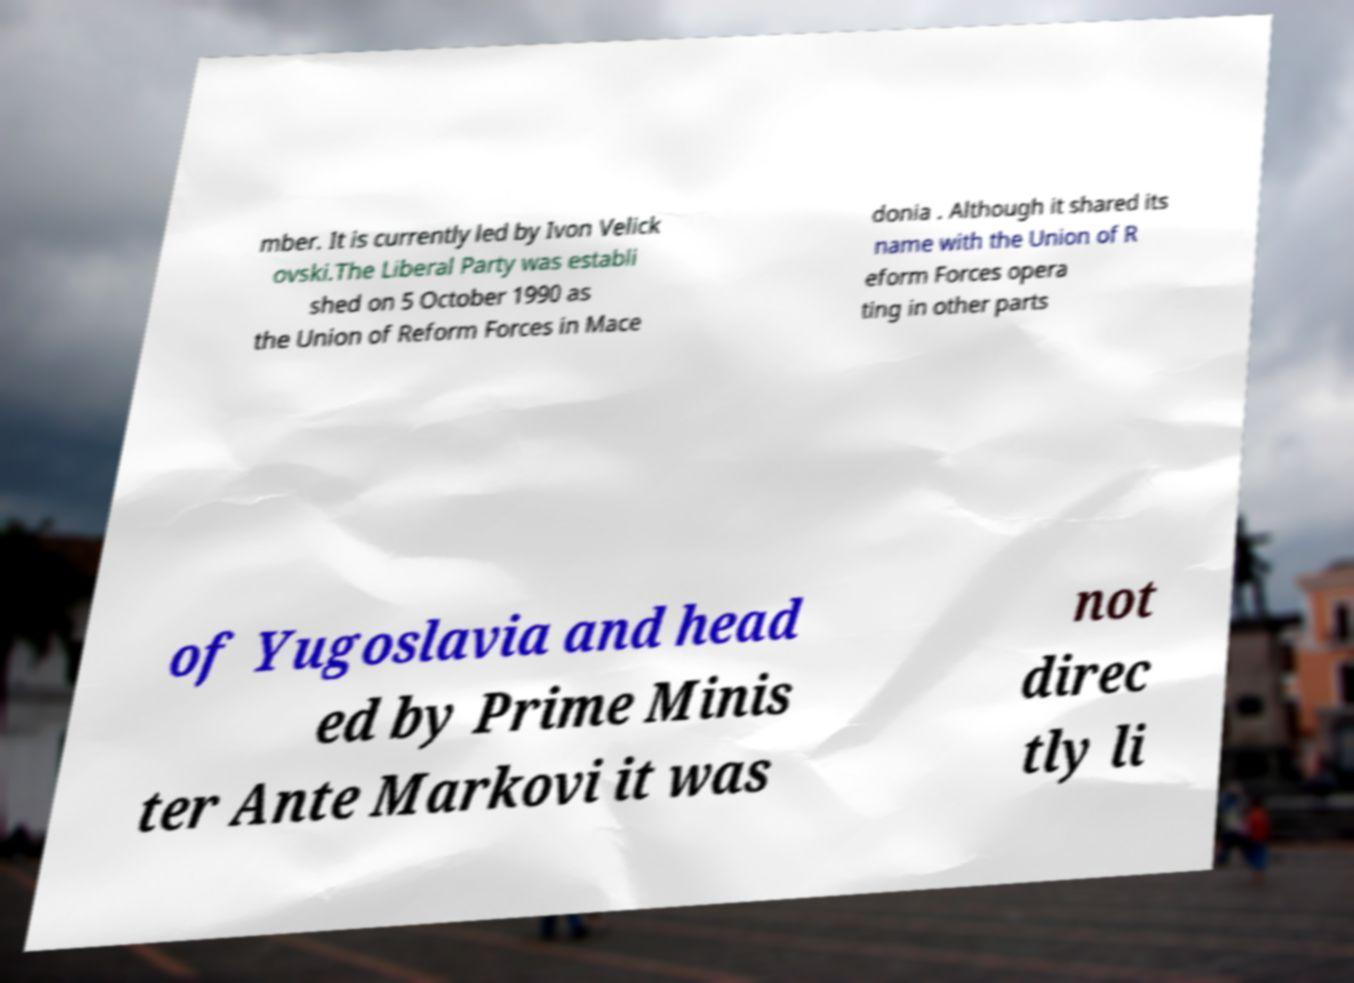Please identify and transcribe the text found in this image. mber. It is currently led by Ivon Velick ovski.The Liberal Party was establi shed on 5 October 1990 as the Union of Reform Forces in Mace donia . Although it shared its name with the Union of R eform Forces opera ting in other parts of Yugoslavia and head ed by Prime Minis ter Ante Markovi it was not direc tly li 